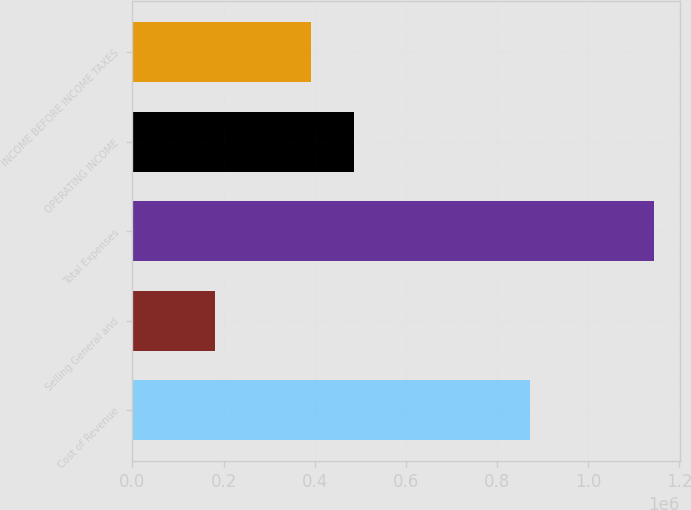Convert chart to OTSL. <chart><loc_0><loc_0><loc_500><loc_500><bar_chart><fcel>Cost of Revenue<fcel>Selling General and<fcel>Total Expenses<fcel>OPERATING INCOME<fcel>INCOME BEFORE INCOME TAXES<nl><fcel>873642<fcel>182146<fcel>1.14423e+06<fcel>487233<fcel>391024<nl></chart> 